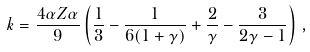<formula> <loc_0><loc_0><loc_500><loc_500>k = \frac { 4 \alpha Z \alpha } { 9 } \left ( \frac { 1 } { 3 } - \frac { 1 } { 6 ( 1 + \gamma ) } + \frac { 2 } { \gamma } - \frac { 3 } { 2 \gamma - 1 } \right ) \, ,</formula> 